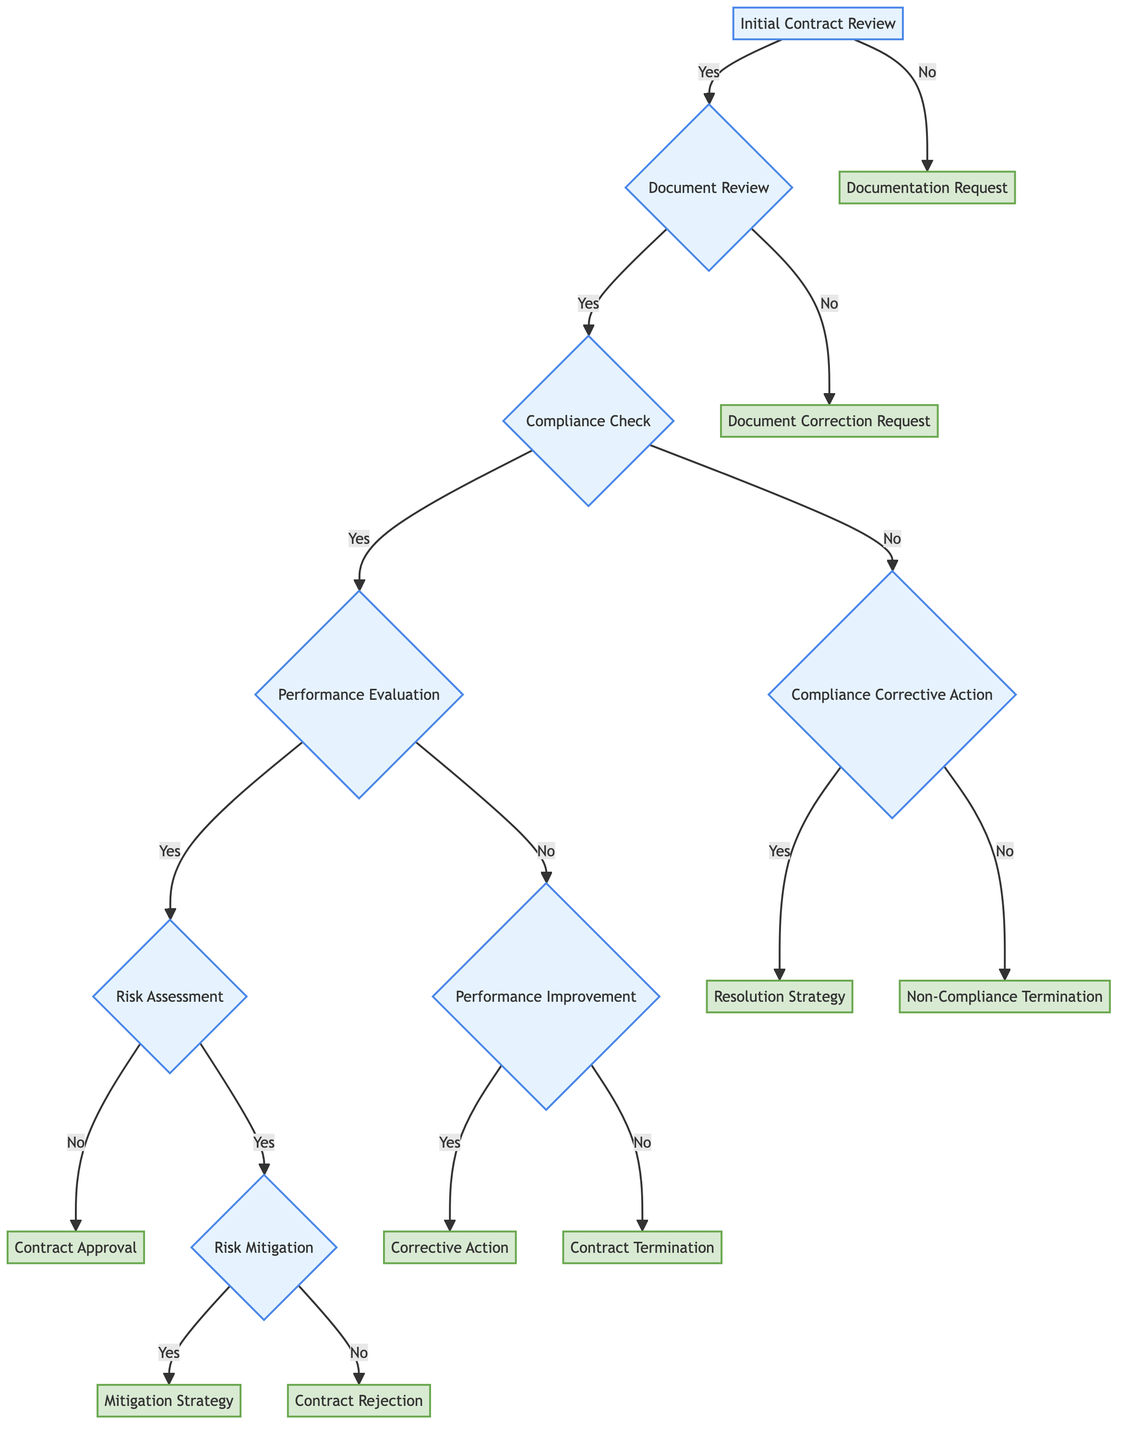What is the first step in the decision tree? The first step is the "Initial Contract Review," which is the starting point of assessing vendor compliance.
Answer: Initial Contract Review How many outcomes are there from the "Document Review" node? The "Document Review" node has two outcomes: one is "Compliance Check" and the other is "Document Correction Request."
Answer: 2 What action is taken if documents are incomplete and inaccurate? If the documents are incomplete and inaccurate, a "Document Correction Request" is made to the vendor to submit corrected or additional documentation.
Answer: Document Correction Request What happens if the vendor does not meet all compliance requirements? If the vendor does not meet all compliance requirements, the next step is "Compliance Corrective Action."
Answer: Compliance Corrective Action What action follows if there is no risk associated with the vendor's performance? If there is no risk associated with the vendor's performance, the next action is "Contract Approval," and the process continues with monitoring.
Answer: Contract Approval Can risks associated with vendor performance be mitigated? Yes, if there are identified risks, the question is whether they can be mitigated, leading to either a "Mitigation Strategy" or "Contract Rejection."
Answer: Yes What is the action taken if the performance issues cannot be corrected? If the performance issues cannot be corrected, the action taken will be "Contract Termination" due to poor performance.
Answer: Contract Termination What is implemented if compliance issues can be resolved? If compliance issues can be resolved, a "Resolution Strategy" is implemented, necessitating the changes to meet compliance.
Answer: Resolution Strategy What is the final outcome if the vendor fails to comply with the compliance requirements? If the vendor fails to comply with the compliance requirements and cannot resolve the issues, the final outcome is "Non-Compliance Termination."
Answer: Non-Compliance Termination 